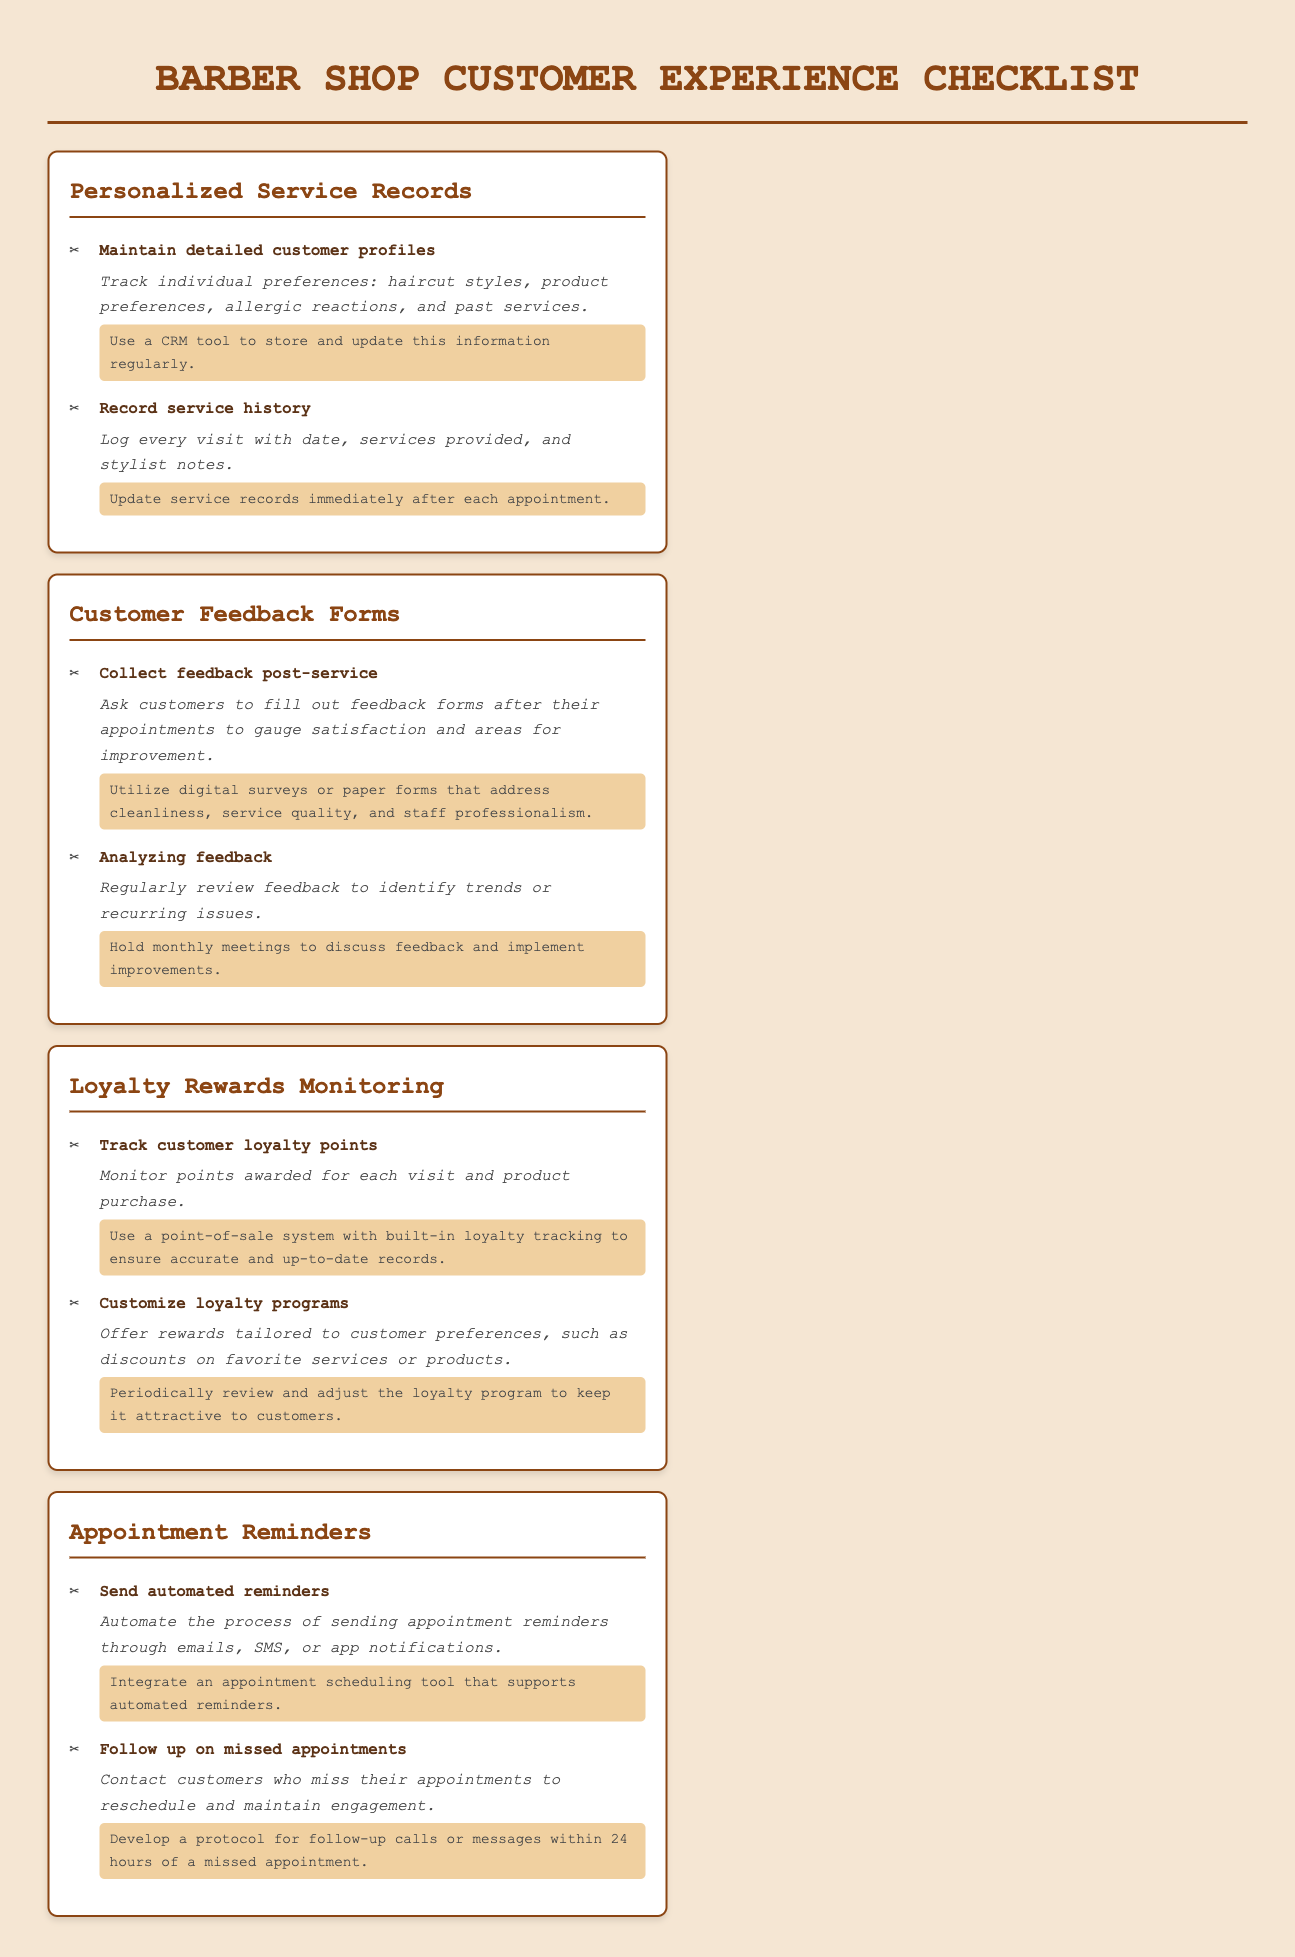What is the title of the document? The title is presented as the main heading in the document, which summarizes its purpose.
Answer: Barber Shop Customer Experience Checklist How many sections are in the checklist? The number of sections is indicated by the main headings within the checklist, each representing a specific area.
Answer: Four What action item suggests using a CRM tool? This action item falls under the section dedicated to maintaining detailed customer profiles, aiming to store and update information.
Answer: Use a CRM tool to store and update this information regularly What is collected post-service? The document mentions an activity that should happen after each service to gauge customer satisfaction.
Answer: Feedback How often should feedback be analyzed? The document specifies a frequency for reviewing collected feedback to identify trends or issues.
Answer: Monthly What should be monitored according to the loyalty rewards section? This term relates to the tracking of rewards given to customers based on their visits and purchases.
Answer: Customer loyalty points What is suggested for reminding customers about appointments? The document talks about automating this process to ensure customers are notified.
Answer: Automated reminders What protocol is mentioned for missed appointments? The document describes a specific strategy to keep engagement after appointments are missed.
Answer: Follow-up calls or messages within 24 hours 